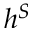<formula> <loc_0><loc_0><loc_500><loc_500>h ^ { S }</formula> 